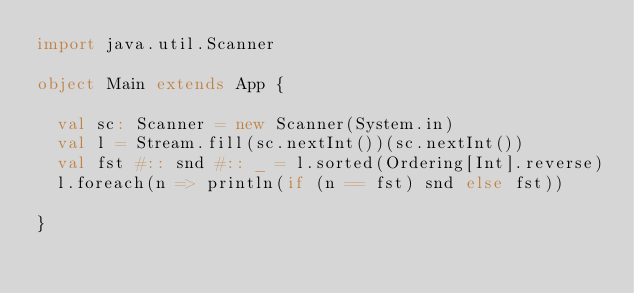Convert code to text. <code><loc_0><loc_0><loc_500><loc_500><_Scala_>import java.util.Scanner

object Main extends App {

  val sc: Scanner = new Scanner(System.in)
  val l = Stream.fill(sc.nextInt())(sc.nextInt())
  val fst #:: snd #:: _ = l.sorted(Ordering[Int].reverse)
  l.foreach(n => println(if (n == fst) snd else fst))

}</code> 